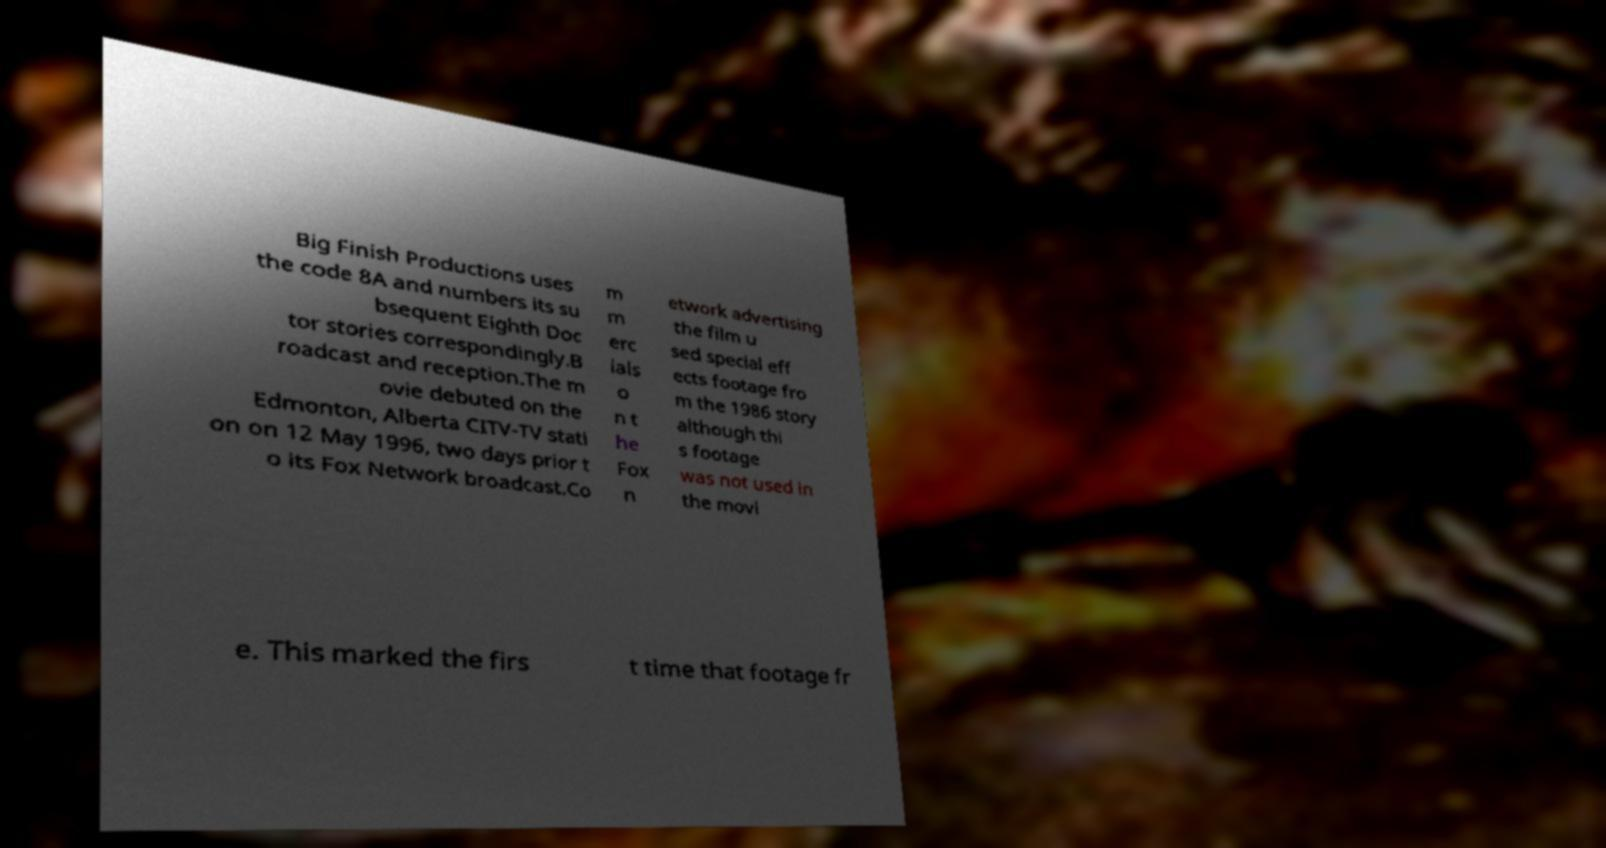What messages or text are displayed in this image? I need them in a readable, typed format. Big Finish Productions uses the code 8A and numbers its su bsequent Eighth Doc tor stories correspondingly.B roadcast and reception.The m ovie debuted on the Edmonton, Alberta CITV-TV stati on on 12 May 1996, two days prior t o its Fox Network broadcast.Co m m erc ials o n t he Fox n etwork advertising the film u sed special eff ects footage fro m the 1986 story although thi s footage was not used in the movi e. This marked the firs t time that footage fr 